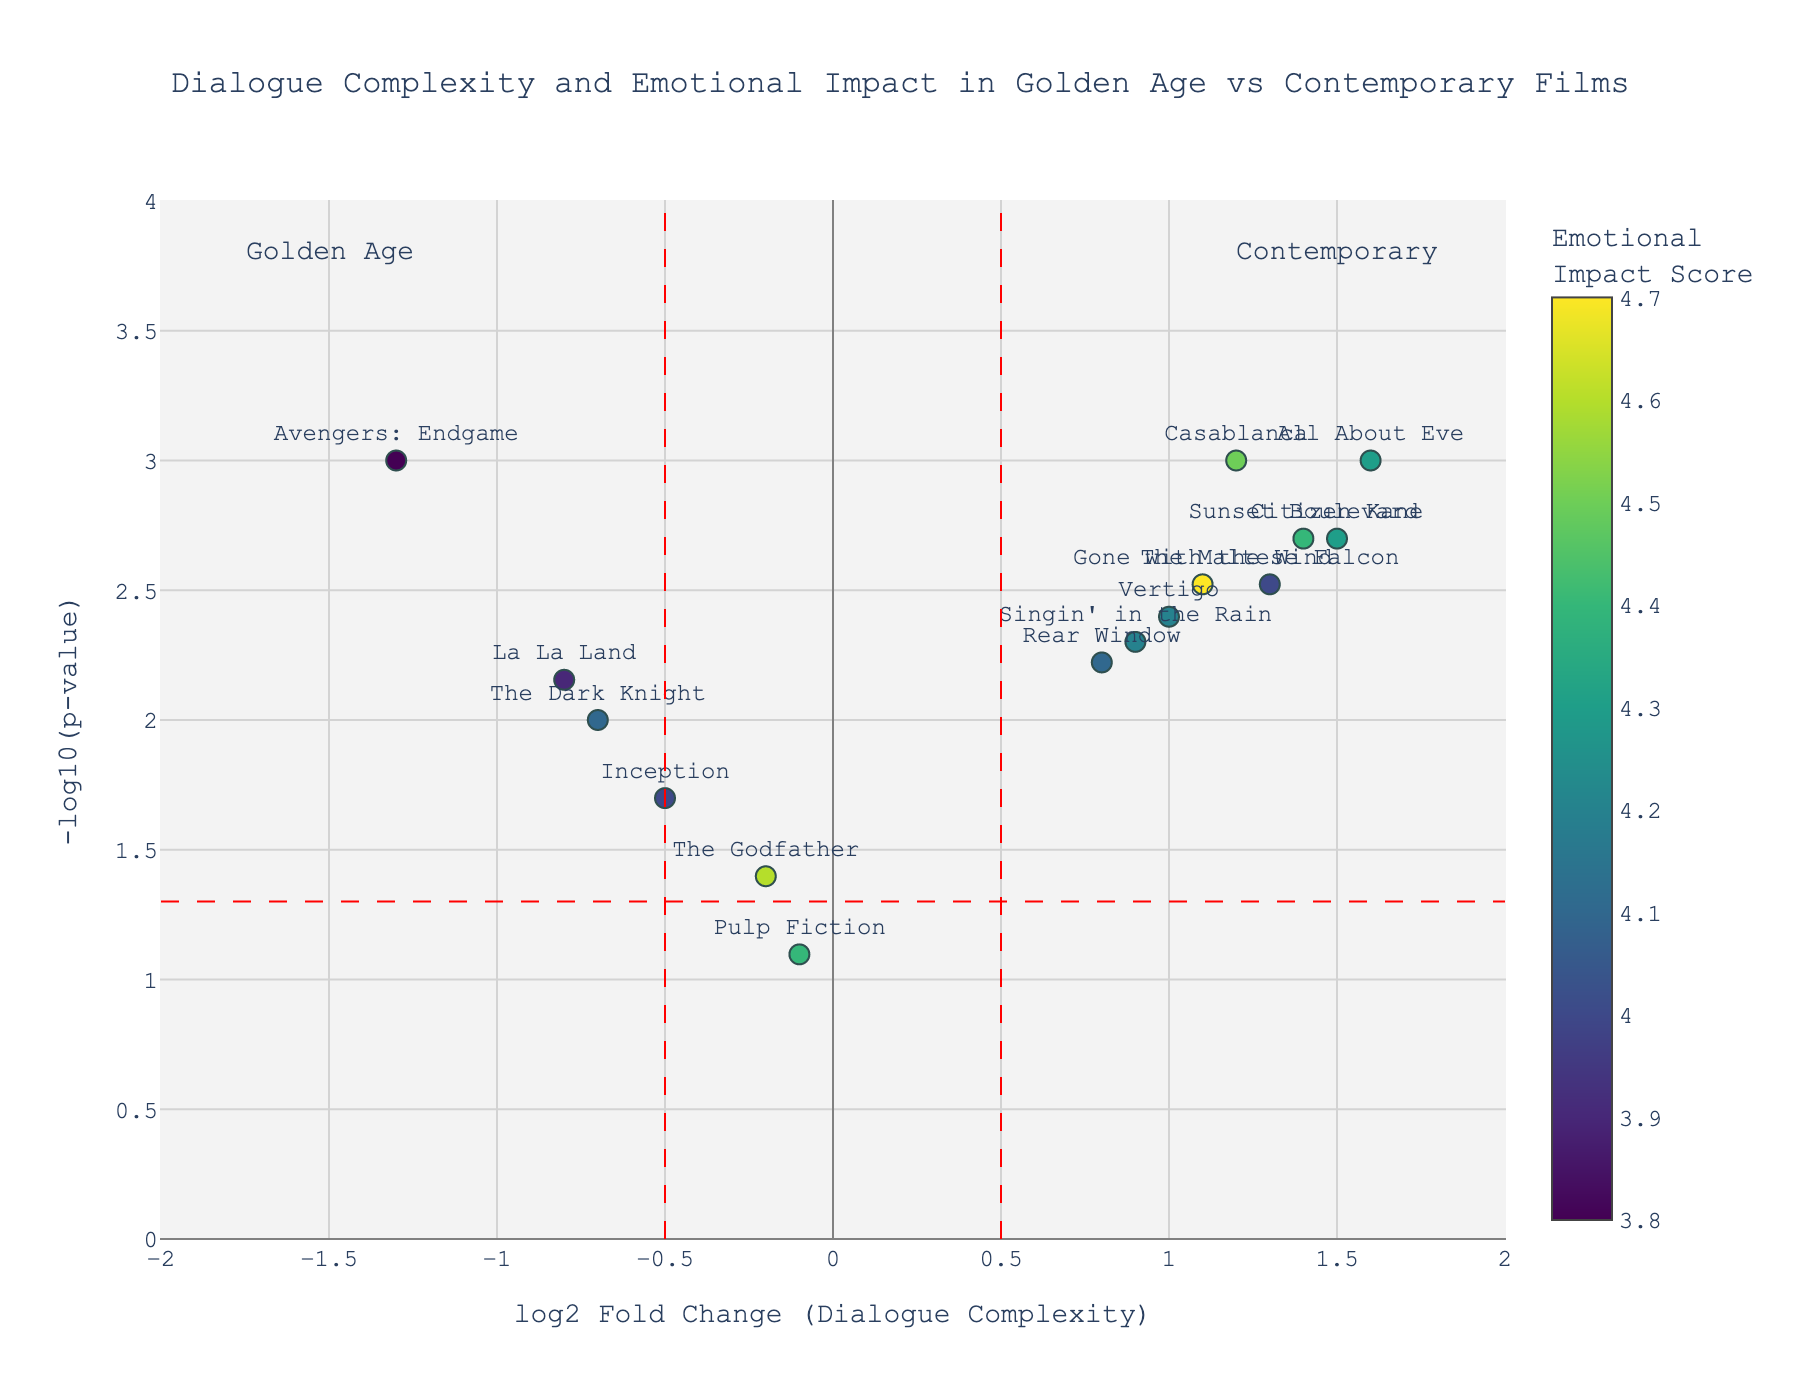What does the x-axis represent in the plot? The x-axis represents the log2 Fold Change in Dialogue Complexity, showing how much the dialogue complexity in Golden Age films differs from contemporary blockbusters.
Answer: log2 Fold Change (Dialogue Complexity) How many data points are represented in the plot? Each data point in the plot corresponds to one screenplay. There are 15 screenplays listed in the data, so the plot will have 15 data points.
Answer: 15 Which screenplay has the highest significance score? The highest significance score is indicated by the greatest -log10(p-value). From the plot, "Casablanca" has a high -log10(p-value).
Answer: Casablanca What does the color scale represent in the plot? The color scale represents the Emotional Impact Score of the screenplays. Lighter colors indicate higher emotional impact.
Answer: Emotional Impact Score Which screenplay has the lowest dialogue complexity relative to contemporary blockbusters? The screenplay with the lowest log2FoldChange indicates the lowest dialogue complexity compared to contemporary blockbusters. From the plot, "Avengers: Endgame" has the lowest log2FoldChange.
Answer: Avengers: Endgame How many screenplays have a positive log2FoldChange and a significance score greater than 2? We need to count the data points with both a positive log2FoldChange and a significance score greater than 2. From the plot, the significant screenplays are "Casablanca", "Citizen Kane", "Sunset Boulevard", "All About Eve", "Vertigo", and "The Maltese Falcon".
Answer: 6 Which screenplay has the highest Emotional Impact Score among those with a negative log2FoldChange? For the screenplays with a negative log2FoldChange, the Emotional Impact Score can be determined by the lighter color from the color scale. Comparing them, "The Dark Knight" has the highest score with an Emotional Impact Score of 4.1.
Answer: The Dark Knight What threshold lines are added to the plot and what do they signify? The plot has vertical lines at log2FoldChange values of -0.5 and 0.5, indicating thresholds for significant fold change, and a horizontal line at -log10(p-value) corresponding to a p-value 0.05, indicating the threshold for statistical significance.
Answer: log2FoldChange thresholds and p-value threshold Which film from the Golden Age has the highest dialogue complexity relative to contemporary blockbusters? Among Golden Age films, the screenplay with the highest log2FoldChange is "All About Eve".
Answer: All About Eve How does the overall emotional impact of Golden Age films compare to contemporary blockbusters? By observing the color scale, many Golden Age films (positive log2FoldChange) are colored lighter, indicating higher Emotional Impact Scores compared to contemporary blockbusters (negative log2FoldChange).
Answer: Golden Age films have higher emotional impact 